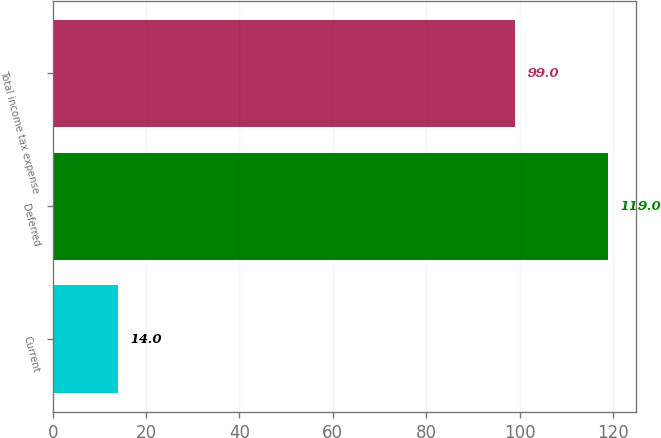Convert chart to OTSL. <chart><loc_0><loc_0><loc_500><loc_500><bar_chart><fcel>Current<fcel>Deferred<fcel>Total income tax expense<nl><fcel>14<fcel>119<fcel>99<nl></chart> 